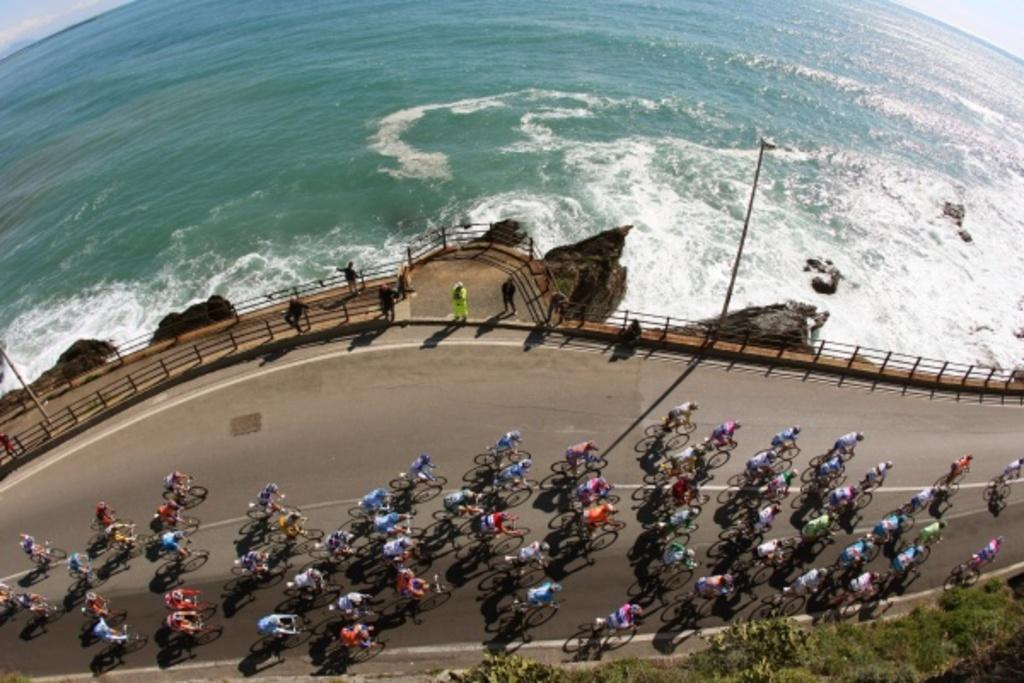How many people can be seen in the image? There are many people in the image. What are the people doing in the image? The people are riding bicycles. Where are the bicycles located? The bicycles are on a road. What can be seen in the background of the image? There is an ocean visible in the background of the image. What type of straw is being used to catch fish in the image? There is no straw or fishing activity present in the image. How is the kettle being used in the image? There is no kettle present in the image. 